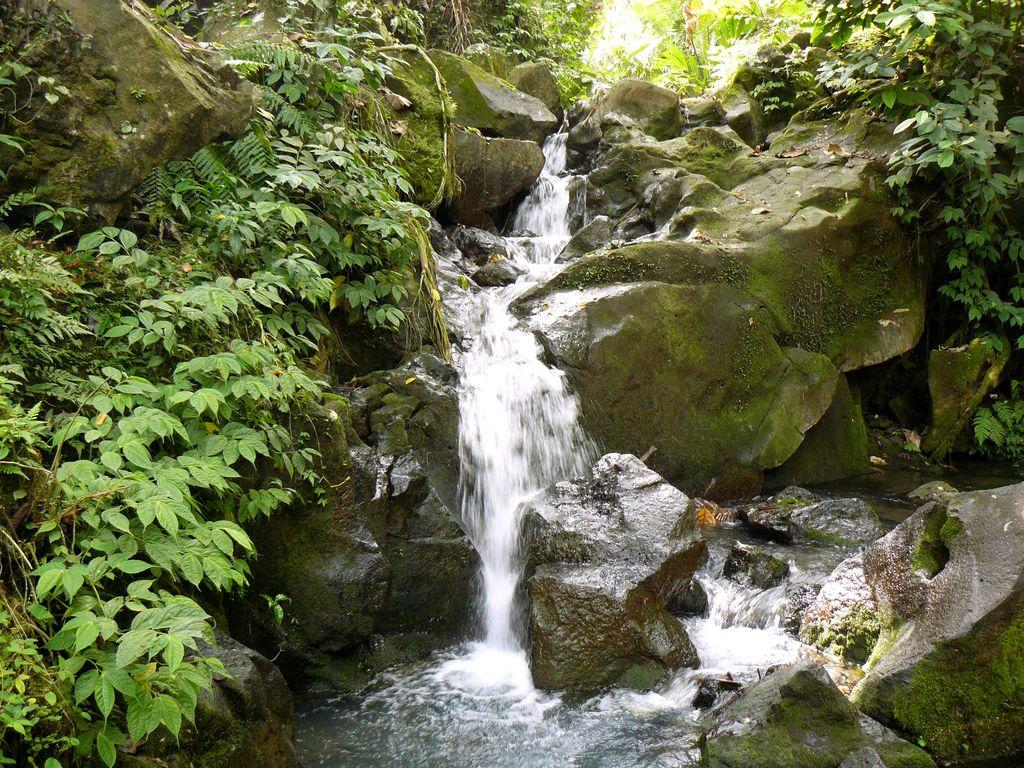What is the primary feature of the landscape in the image? There are many rocks in the image. Is there any water feature present among the rocks? Yes, there is a waterfall between the rocks. What type of vegetation can be seen in the image? There are leaves and plants in the image. What can be seen at the bottom of the image? There is water visible at the bottom of the image. Where is the camp located in the image? There is no camp present in the image. What type of arch can be seen in the image? There is no arch present in the image. 